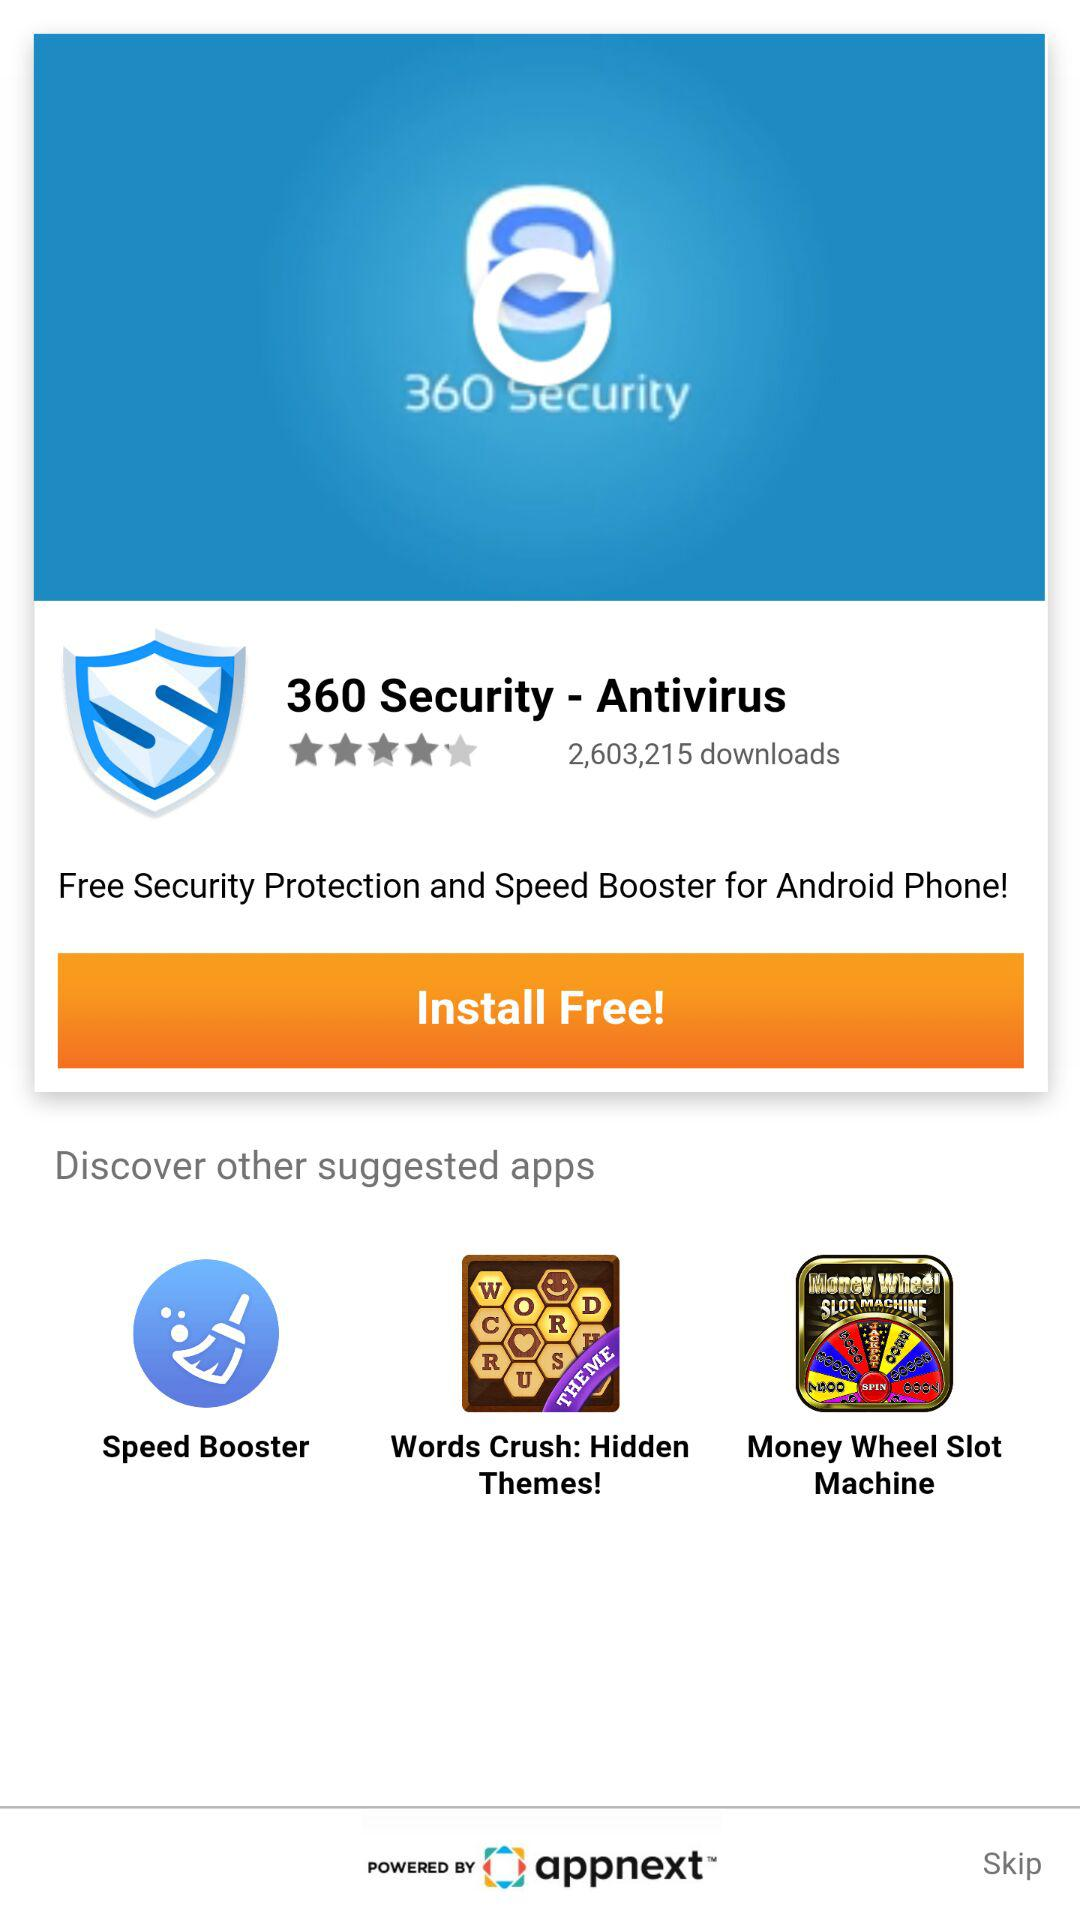How many downloads are there? There are 2,603,215 downloads. 